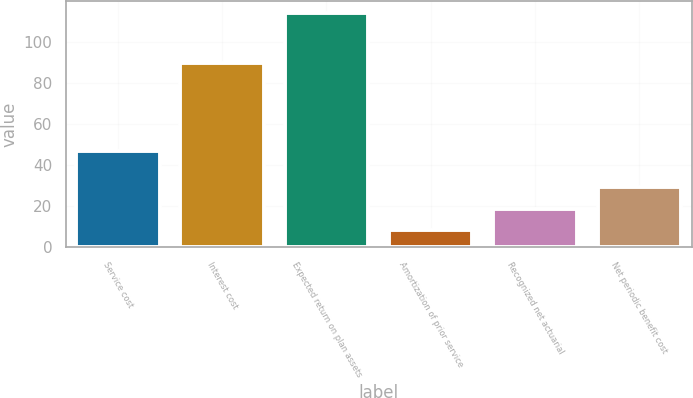<chart> <loc_0><loc_0><loc_500><loc_500><bar_chart><fcel>Service cost<fcel>Interest cost<fcel>Expected return on plan assets<fcel>Amortization of prior service<fcel>Recognized net actuarial<fcel>Net periodic benefit cost<nl><fcel>47.1<fcel>89.5<fcel>114.2<fcel>8.3<fcel>18.89<fcel>29.48<nl></chart> 